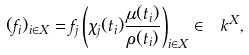Convert formula to latex. <formula><loc_0><loc_0><loc_500><loc_500>( f _ { i } ) _ { i \in X } = f _ { j } \left ( \chi _ { j } ( t _ { i } ) \frac { \mu ( t _ { i } ) } { \rho ( t _ { i } ) } \right ) _ { i \in X } \in \ k ^ { X } ,</formula> 